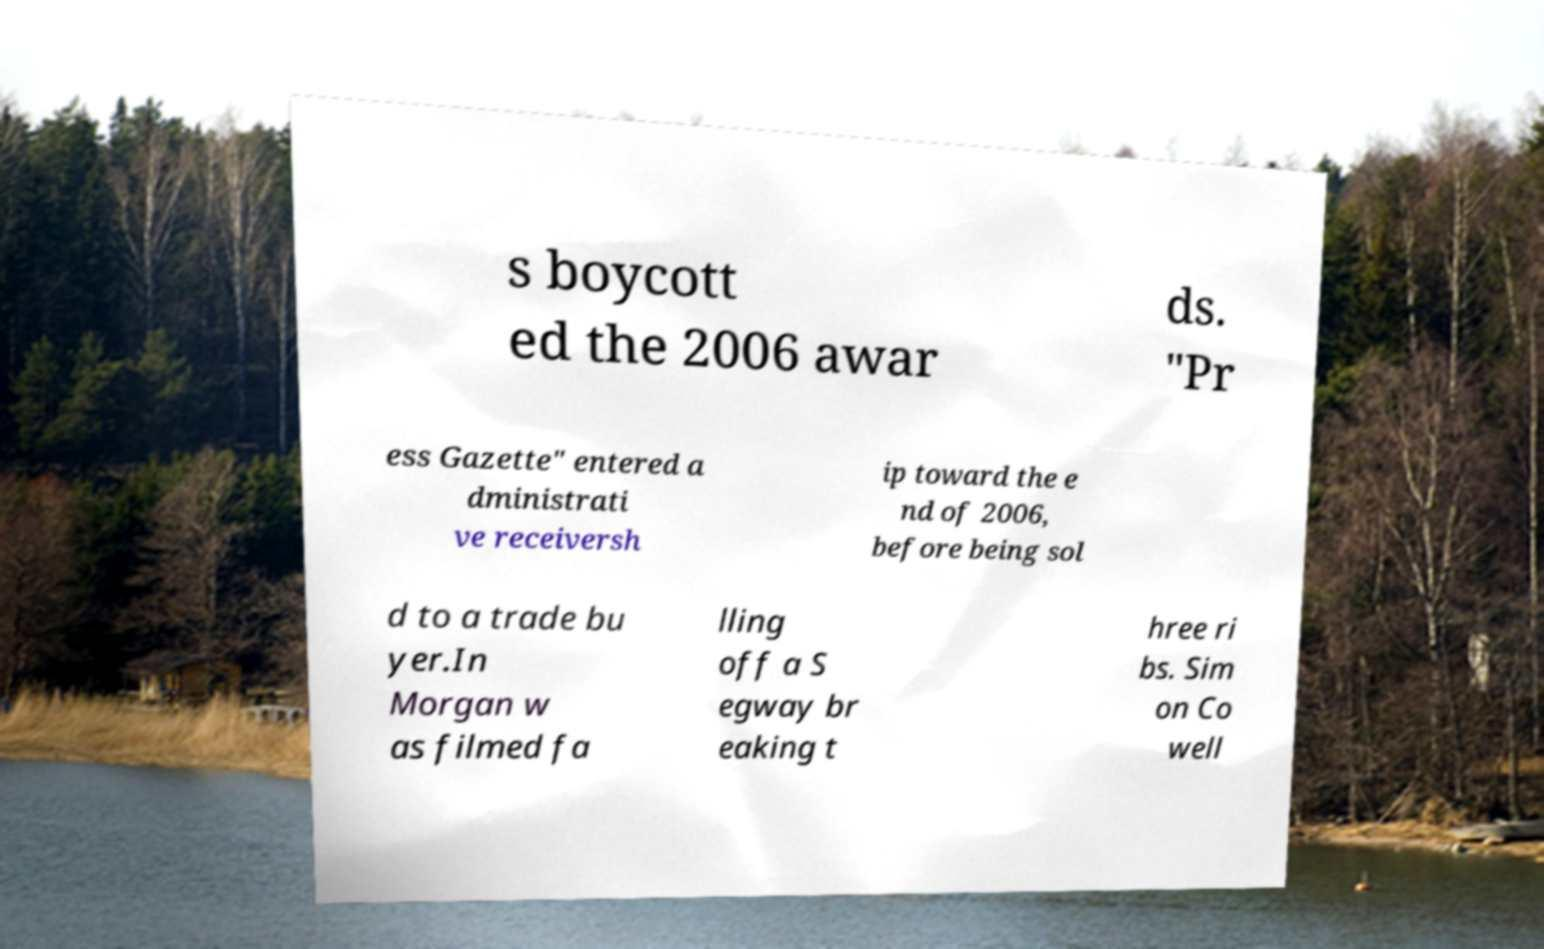There's text embedded in this image that I need extracted. Can you transcribe it verbatim? s boycott ed the 2006 awar ds. "Pr ess Gazette" entered a dministrati ve receiversh ip toward the e nd of 2006, before being sol d to a trade bu yer.In Morgan w as filmed fa lling off a S egway br eaking t hree ri bs. Sim on Co well 